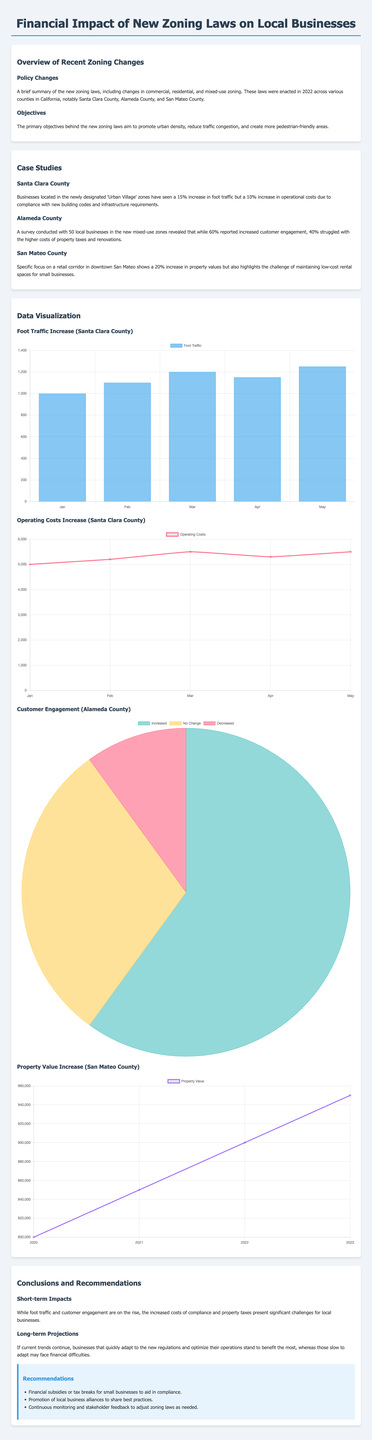What is the percentage increase in foot traffic in Santa Clara County? The document states that businesses in the 'Urban Village' zones of Santa Clara County have seen a 15% increase in foot traffic.
Answer: 15% What is the reported percentage of businesses experiencing increased customer engagement in Alameda County? According to the document, 60% of businesses in Alameda County reported increased customer engagement.
Answer: 60% What percentage of businesses in Alameda County faced higher costs? The document mentions that 40% of businesses in Alameda County struggled with the higher costs of property taxes and renovations.
Answer: 40% What is the increase in property values observed in San Mateo County? The document indicates that there is a 20% increase in property values in San Mateo County.
Answer: 20% What is the total duration covered for the property value increase chart? The chart for property values provides data for the years 2020 to 2023.
Answer: 2020 to 2023 What type of chart is used to represent customer engagement in Alameda County? The document specifies that a pie chart is used for representing customer engagement in Alameda County.
Answer: Pie chart What are two recommended actions mentioned to assist small businesses? The document recommends financial subsidies or tax breaks and promotion of local business alliances for small businesses.
Answer: Financial subsidies or tax breaks; promotion of local business alliances What was the primary objective of the new zoning laws? The primary objective behind the new zoning laws is to promote urban density.
Answer: Promote urban density 